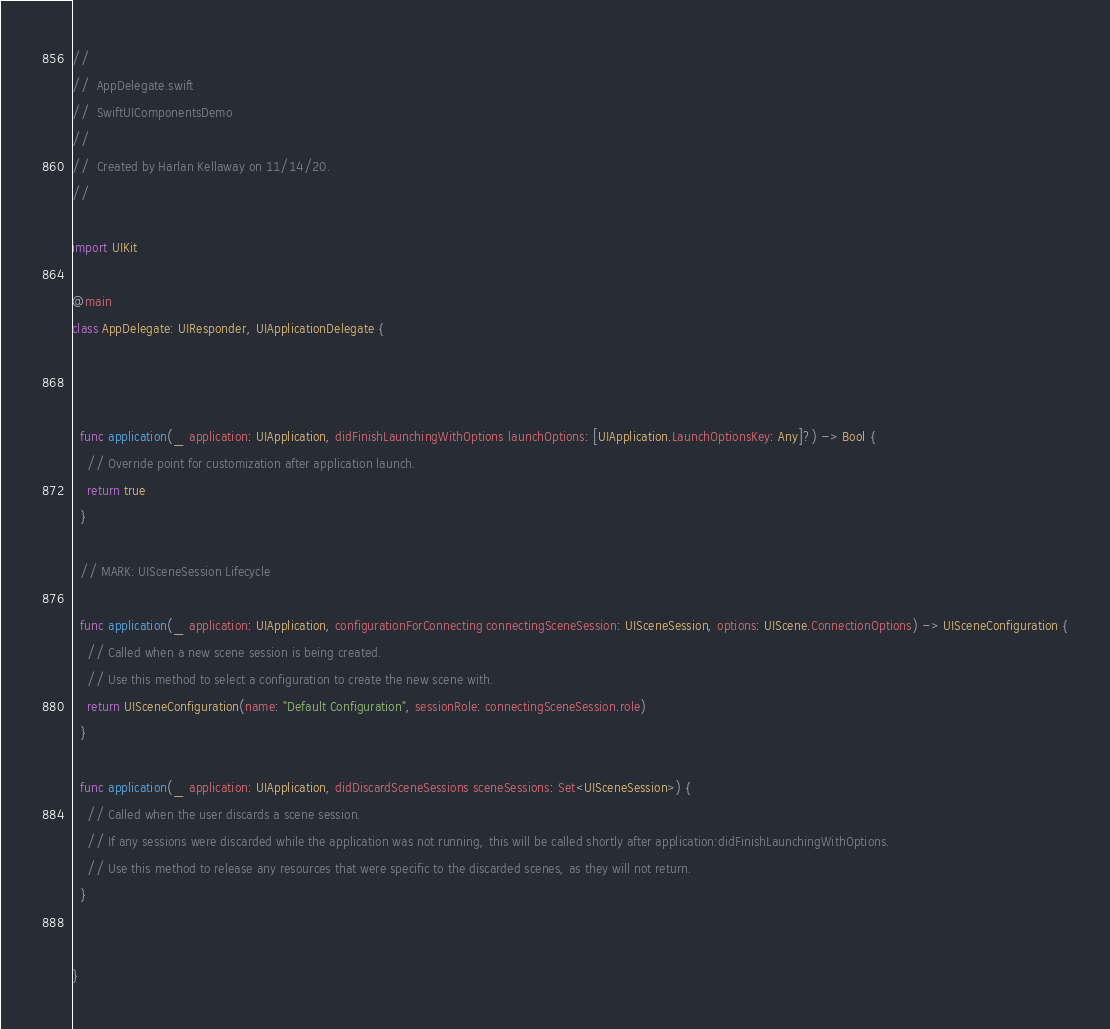<code> <loc_0><loc_0><loc_500><loc_500><_Swift_>//
//  AppDelegate.swift
//  SwiftUIComponentsDemo
//
//  Created by Harlan Kellaway on 11/14/20.
//

import UIKit

@main
class AppDelegate: UIResponder, UIApplicationDelegate {



  func application(_ application: UIApplication, didFinishLaunchingWithOptions launchOptions: [UIApplication.LaunchOptionsKey: Any]?) -> Bool {
    // Override point for customization after application launch.
    return true
  }

  // MARK: UISceneSession Lifecycle

  func application(_ application: UIApplication, configurationForConnecting connectingSceneSession: UISceneSession, options: UIScene.ConnectionOptions) -> UISceneConfiguration {
    // Called when a new scene session is being created.
    // Use this method to select a configuration to create the new scene with.
    return UISceneConfiguration(name: "Default Configuration", sessionRole: connectingSceneSession.role)
  }

  func application(_ application: UIApplication, didDiscardSceneSessions sceneSessions: Set<UISceneSession>) {
    // Called when the user discards a scene session.
    // If any sessions were discarded while the application was not running, this will be called shortly after application:didFinishLaunchingWithOptions.
    // Use this method to release any resources that were specific to the discarded scenes, as they will not return.
  }


}

</code> 